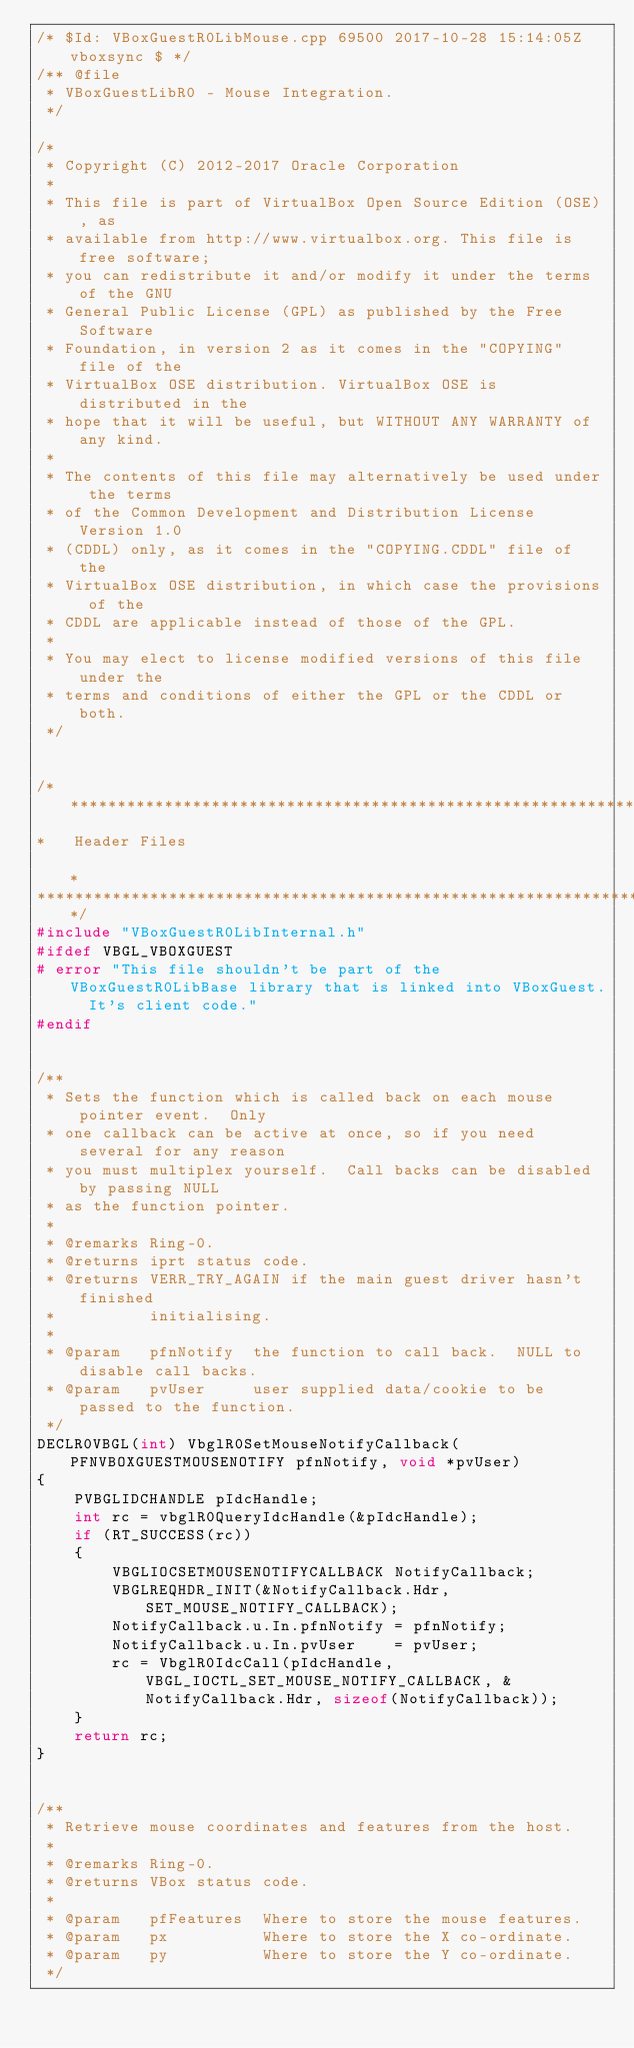<code> <loc_0><loc_0><loc_500><loc_500><_C++_>/* $Id: VBoxGuestR0LibMouse.cpp 69500 2017-10-28 15:14:05Z vboxsync $ */
/** @file
 * VBoxGuestLibR0 - Mouse Integration.
 */

/*
 * Copyright (C) 2012-2017 Oracle Corporation
 *
 * This file is part of VirtualBox Open Source Edition (OSE), as
 * available from http://www.virtualbox.org. This file is free software;
 * you can redistribute it and/or modify it under the terms of the GNU
 * General Public License (GPL) as published by the Free Software
 * Foundation, in version 2 as it comes in the "COPYING" file of the
 * VirtualBox OSE distribution. VirtualBox OSE is distributed in the
 * hope that it will be useful, but WITHOUT ANY WARRANTY of any kind.
 *
 * The contents of this file may alternatively be used under the terms
 * of the Common Development and Distribution License Version 1.0
 * (CDDL) only, as it comes in the "COPYING.CDDL" file of the
 * VirtualBox OSE distribution, in which case the provisions of the
 * CDDL are applicable instead of those of the GPL.
 *
 * You may elect to license modified versions of this file under the
 * terms and conditions of either the GPL or the CDDL or both.
 */


/*********************************************************************************************************************************
*   Header Files                                                                                                                 *
*********************************************************************************************************************************/
#include "VBoxGuestR0LibInternal.h"
#ifdef VBGL_VBOXGUEST
# error "This file shouldn't be part of the VBoxGuestR0LibBase library that is linked into VBoxGuest.  It's client code."
#endif


/**
 * Sets the function which is called back on each mouse pointer event.  Only
 * one callback can be active at once, so if you need several for any reason
 * you must multiplex yourself.  Call backs can be disabled by passing NULL
 * as the function pointer.
 *
 * @remarks Ring-0.
 * @returns iprt status code.
 * @returns VERR_TRY_AGAIN if the main guest driver hasn't finished
 *          initialising.
 *
 * @param   pfnNotify  the function to call back.  NULL to disable call backs.
 * @param   pvUser     user supplied data/cookie to be passed to the function.
 */
DECLR0VBGL(int) VbglR0SetMouseNotifyCallback(PFNVBOXGUESTMOUSENOTIFY pfnNotify, void *pvUser)
{
    PVBGLIDCHANDLE pIdcHandle;
    int rc = vbglR0QueryIdcHandle(&pIdcHandle);
    if (RT_SUCCESS(rc))
    {
        VBGLIOCSETMOUSENOTIFYCALLBACK NotifyCallback;
        VBGLREQHDR_INIT(&NotifyCallback.Hdr, SET_MOUSE_NOTIFY_CALLBACK);
        NotifyCallback.u.In.pfnNotify = pfnNotify;
        NotifyCallback.u.In.pvUser    = pvUser;
        rc = VbglR0IdcCall(pIdcHandle, VBGL_IOCTL_SET_MOUSE_NOTIFY_CALLBACK, &NotifyCallback.Hdr, sizeof(NotifyCallback));
    }
    return rc;
}


/**
 * Retrieve mouse coordinates and features from the host.
 *
 * @remarks Ring-0.
 * @returns VBox status code.
 *
 * @param   pfFeatures  Where to store the mouse features.
 * @param   px          Where to store the X co-ordinate.
 * @param   py          Where to store the Y co-ordinate.
 */</code> 